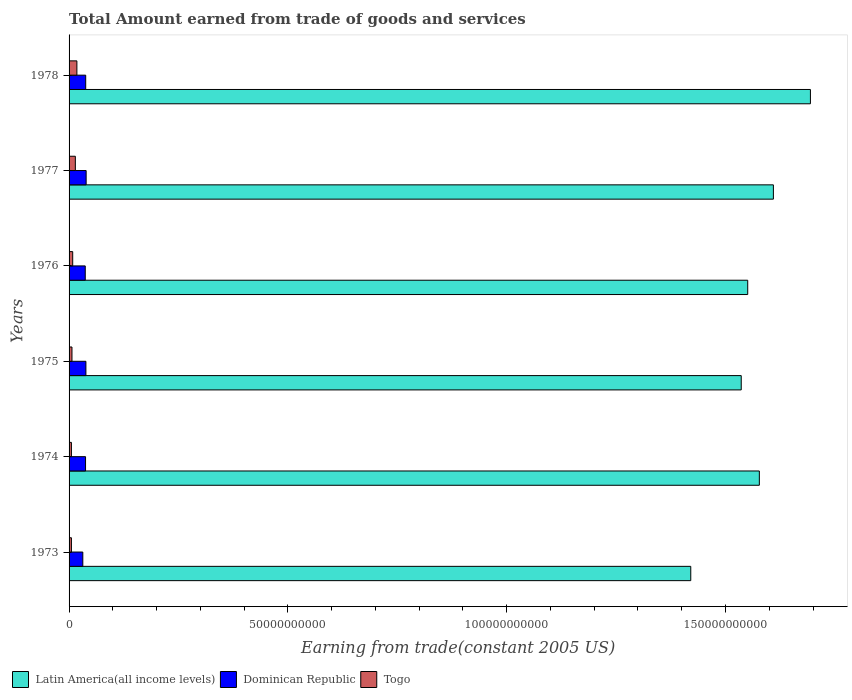Are the number of bars per tick equal to the number of legend labels?
Make the answer very short. Yes. How many bars are there on the 3rd tick from the bottom?
Provide a succinct answer. 3. What is the label of the 1st group of bars from the top?
Your response must be concise. 1978. What is the total amount earned by trading goods and services in Dominican Republic in 1973?
Offer a terse response. 3.14e+09. Across all years, what is the maximum total amount earned by trading goods and services in Dominican Republic?
Your answer should be compact. 3.90e+09. Across all years, what is the minimum total amount earned by trading goods and services in Togo?
Ensure brevity in your answer.  5.37e+08. In which year was the total amount earned by trading goods and services in Togo maximum?
Your response must be concise. 1978. What is the total total amount earned by trading goods and services in Latin America(all income levels) in the graph?
Provide a short and direct response. 9.39e+11. What is the difference between the total amount earned by trading goods and services in Latin America(all income levels) in 1974 and that in 1975?
Ensure brevity in your answer.  4.14e+09. What is the difference between the total amount earned by trading goods and services in Dominican Republic in 1977 and the total amount earned by trading goods and services in Togo in 1975?
Offer a terse response. 3.24e+09. What is the average total amount earned by trading goods and services in Togo per year?
Offer a very short reply. 9.64e+08. In the year 1974, what is the difference between the total amount earned by trading goods and services in Togo and total amount earned by trading goods and services in Latin America(all income levels)?
Your answer should be compact. -1.57e+11. What is the ratio of the total amount earned by trading goods and services in Togo in 1973 to that in 1974?
Provide a succinct answer. 1. What is the difference between the highest and the second highest total amount earned by trading goods and services in Dominican Republic?
Keep it short and to the point. 5.34e+07. What is the difference between the highest and the lowest total amount earned by trading goods and services in Togo?
Give a very brief answer. 1.25e+09. What does the 1st bar from the top in 1973 represents?
Give a very brief answer. Togo. What does the 3rd bar from the bottom in 1975 represents?
Your response must be concise. Togo. Is it the case that in every year, the sum of the total amount earned by trading goods and services in Dominican Republic and total amount earned by trading goods and services in Latin America(all income levels) is greater than the total amount earned by trading goods and services in Togo?
Provide a short and direct response. Yes. How many bars are there?
Give a very brief answer. 18. How many years are there in the graph?
Offer a terse response. 6. Does the graph contain any zero values?
Offer a terse response. No. Does the graph contain grids?
Offer a terse response. No. How many legend labels are there?
Provide a succinct answer. 3. How are the legend labels stacked?
Your answer should be compact. Horizontal. What is the title of the graph?
Your answer should be compact. Total Amount earned from trade of goods and services. Does "Burundi" appear as one of the legend labels in the graph?
Make the answer very short. No. What is the label or title of the X-axis?
Ensure brevity in your answer.  Earning from trade(constant 2005 US). What is the label or title of the Y-axis?
Keep it short and to the point. Years. What is the Earning from trade(constant 2005 US) in Latin America(all income levels) in 1973?
Your answer should be compact. 1.42e+11. What is the Earning from trade(constant 2005 US) of Dominican Republic in 1973?
Offer a very short reply. 3.14e+09. What is the Earning from trade(constant 2005 US) of Togo in 1973?
Your answer should be very brief. 5.37e+08. What is the Earning from trade(constant 2005 US) in Latin America(all income levels) in 1974?
Provide a short and direct response. 1.58e+11. What is the Earning from trade(constant 2005 US) in Dominican Republic in 1974?
Your answer should be very brief. 3.77e+09. What is the Earning from trade(constant 2005 US) of Togo in 1974?
Provide a succinct answer. 5.37e+08. What is the Earning from trade(constant 2005 US) in Latin America(all income levels) in 1975?
Offer a terse response. 1.54e+11. What is the Earning from trade(constant 2005 US) of Dominican Republic in 1975?
Provide a short and direct response. 3.85e+09. What is the Earning from trade(constant 2005 US) of Togo in 1975?
Provide a succinct answer. 6.61e+08. What is the Earning from trade(constant 2005 US) of Latin America(all income levels) in 1976?
Your response must be concise. 1.55e+11. What is the Earning from trade(constant 2005 US) of Dominican Republic in 1976?
Offer a terse response. 3.70e+09. What is the Earning from trade(constant 2005 US) in Togo in 1976?
Give a very brief answer. 8.29e+08. What is the Earning from trade(constant 2005 US) in Latin America(all income levels) in 1977?
Offer a terse response. 1.61e+11. What is the Earning from trade(constant 2005 US) of Dominican Republic in 1977?
Ensure brevity in your answer.  3.90e+09. What is the Earning from trade(constant 2005 US) in Togo in 1977?
Provide a short and direct response. 1.43e+09. What is the Earning from trade(constant 2005 US) of Latin America(all income levels) in 1978?
Provide a succinct answer. 1.69e+11. What is the Earning from trade(constant 2005 US) of Dominican Republic in 1978?
Offer a terse response. 3.80e+09. What is the Earning from trade(constant 2005 US) in Togo in 1978?
Provide a short and direct response. 1.79e+09. Across all years, what is the maximum Earning from trade(constant 2005 US) in Latin America(all income levels)?
Give a very brief answer. 1.69e+11. Across all years, what is the maximum Earning from trade(constant 2005 US) in Dominican Republic?
Make the answer very short. 3.90e+09. Across all years, what is the maximum Earning from trade(constant 2005 US) in Togo?
Your answer should be very brief. 1.79e+09. Across all years, what is the minimum Earning from trade(constant 2005 US) of Latin America(all income levels)?
Offer a terse response. 1.42e+11. Across all years, what is the minimum Earning from trade(constant 2005 US) of Dominican Republic?
Provide a succinct answer. 3.14e+09. Across all years, what is the minimum Earning from trade(constant 2005 US) in Togo?
Offer a terse response. 5.37e+08. What is the total Earning from trade(constant 2005 US) of Latin America(all income levels) in the graph?
Give a very brief answer. 9.39e+11. What is the total Earning from trade(constant 2005 US) in Dominican Republic in the graph?
Your answer should be very brief. 2.22e+1. What is the total Earning from trade(constant 2005 US) of Togo in the graph?
Your response must be concise. 5.78e+09. What is the difference between the Earning from trade(constant 2005 US) in Latin America(all income levels) in 1973 and that in 1974?
Make the answer very short. -1.57e+1. What is the difference between the Earning from trade(constant 2005 US) of Dominican Republic in 1973 and that in 1974?
Give a very brief answer. -6.24e+08. What is the difference between the Earning from trade(constant 2005 US) in Togo in 1973 and that in 1974?
Ensure brevity in your answer.  0. What is the difference between the Earning from trade(constant 2005 US) of Latin America(all income levels) in 1973 and that in 1975?
Your answer should be very brief. -1.15e+1. What is the difference between the Earning from trade(constant 2005 US) in Dominican Republic in 1973 and that in 1975?
Provide a succinct answer. -7.05e+08. What is the difference between the Earning from trade(constant 2005 US) in Togo in 1973 and that in 1975?
Keep it short and to the point. -1.24e+08. What is the difference between the Earning from trade(constant 2005 US) of Latin America(all income levels) in 1973 and that in 1976?
Your answer should be compact. -1.30e+1. What is the difference between the Earning from trade(constant 2005 US) of Dominican Republic in 1973 and that in 1976?
Offer a terse response. -5.55e+08. What is the difference between the Earning from trade(constant 2005 US) in Togo in 1973 and that in 1976?
Ensure brevity in your answer.  -2.91e+08. What is the difference between the Earning from trade(constant 2005 US) of Latin America(all income levels) in 1973 and that in 1977?
Ensure brevity in your answer.  -1.89e+1. What is the difference between the Earning from trade(constant 2005 US) of Dominican Republic in 1973 and that in 1977?
Ensure brevity in your answer.  -7.59e+08. What is the difference between the Earning from trade(constant 2005 US) in Togo in 1973 and that in 1977?
Offer a terse response. -8.94e+08. What is the difference between the Earning from trade(constant 2005 US) in Latin America(all income levels) in 1973 and that in 1978?
Offer a terse response. -2.73e+1. What is the difference between the Earning from trade(constant 2005 US) in Dominican Republic in 1973 and that in 1978?
Your answer should be compact. -6.60e+08. What is the difference between the Earning from trade(constant 2005 US) in Togo in 1973 and that in 1978?
Offer a very short reply. -1.25e+09. What is the difference between the Earning from trade(constant 2005 US) of Latin America(all income levels) in 1974 and that in 1975?
Give a very brief answer. 4.14e+09. What is the difference between the Earning from trade(constant 2005 US) in Dominican Republic in 1974 and that in 1975?
Your response must be concise. -8.16e+07. What is the difference between the Earning from trade(constant 2005 US) of Togo in 1974 and that in 1975?
Ensure brevity in your answer.  -1.24e+08. What is the difference between the Earning from trade(constant 2005 US) of Latin America(all income levels) in 1974 and that in 1976?
Give a very brief answer. 2.66e+09. What is the difference between the Earning from trade(constant 2005 US) of Dominican Republic in 1974 and that in 1976?
Ensure brevity in your answer.  6.86e+07. What is the difference between the Earning from trade(constant 2005 US) in Togo in 1974 and that in 1976?
Give a very brief answer. -2.91e+08. What is the difference between the Earning from trade(constant 2005 US) of Latin America(all income levels) in 1974 and that in 1977?
Provide a short and direct response. -3.21e+09. What is the difference between the Earning from trade(constant 2005 US) of Dominican Republic in 1974 and that in 1977?
Your answer should be compact. -1.35e+08. What is the difference between the Earning from trade(constant 2005 US) in Togo in 1974 and that in 1977?
Your response must be concise. -8.94e+08. What is the difference between the Earning from trade(constant 2005 US) of Latin America(all income levels) in 1974 and that in 1978?
Your answer should be compact. -1.17e+1. What is the difference between the Earning from trade(constant 2005 US) in Dominican Republic in 1974 and that in 1978?
Keep it short and to the point. -3.59e+07. What is the difference between the Earning from trade(constant 2005 US) in Togo in 1974 and that in 1978?
Ensure brevity in your answer.  -1.25e+09. What is the difference between the Earning from trade(constant 2005 US) in Latin America(all income levels) in 1975 and that in 1976?
Ensure brevity in your answer.  -1.48e+09. What is the difference between the Earning from trade(constant 2005 US) of Dominican Republic in 1975 and that in 1976?
Ensure brevity in your answer.  1.50e+08. What is the difference between the Earning from trade(constant 2005 US) in Togo in 1975 and that in 1976?
Provide a succinct answer. -1.68e+08. What is the difference between the Earning from trade(constant 2005 US) of Latin America(all income levels) in 1975 and that in 1977?
Your answer should be compact. -7.35e+09. What is the difference between the Earning from trade(constant 2005 US) of Dominican Republic in 1975 and that in 1977?
Give a very brief answer. -5.34e+07. What is the difference between the Earning from trade(constant 2005 US) of Togo in 1975 and that in 1977?
Your response must be concise. -7.71e+08. What is the difference between the Earning from trade(constant 2005 US) of Latin America(all income levels) in 1975 and that in 1978?
Give a very brief answer. -1.58e+1. What is the difference between the Earning from trade(constant 2005 US) in Dominican Republic in 1975 and that in 1978?
Offer a very short reply. 4.57e+07. What is the difference between the Earning from trade(constant 2005 US) in Togo in 1975 and that in 1978?
Make the answer very short. -1.13e+09. What is the difference between the Earning from trade(constant 2005 US) of Latin America(all income levels) in 1976 and that in 1977?
Make the answer very short. -5.86e+09. What is the difference between the Earning from trade(constant 2005 US) of Dominican Republic in 1976 and that in 1977?
Your response must be concise. -2.04e+08. What is the difference between the Earning from trade(constant 2005 US) in Togo in 1976 and that in 1977?
Make the answer very short. -6.03e+08. What is the difference between the Earning from trade(constant 2005 US) in Latin America(all income levels) in 1976 and that in 1978?
Your answer should be compact. -1.43e+1. What is the difference between the Earning from trade(constant 2005 US) in Dominican Republic in 1976 and that in 1978?
Give a very brief answer. -1.05e+08. What is the difference between the Earning from trade(constant 2005 US) in Togo in 1976 and that in 1978?
Your answer should be very brief. -9.59e+08. What is the difference between the Earning from trade(constant 2005 US) in Latin America(all income levels) in 1977 and that in 1978?
Keep it short and to the point. -8.46e+09. What is the difference between the Earning from trade(constant 2005 US) of Dominican Republic in 1977 and that in 1978?
Your response must be concise. 9.90e+07. What is the difference between the Earning from trade(constant 2005 US) in Togo in 1977 and that in 1978?
Offer a terse response. -3.55e+08. What is the difference between the Earning from trade(constant 2005 US) in Latin America(all income levels) in 1973 and the Earning from trade(constant 2005 US) in Dominican Republic in 1974?
Your answer should be very brief. 1.38e+11. What is the difference between the Earning from trade(constant 2005 US) of Latin America(all income levels) in 1973 and the Earning from trade(constant 2005 US) of Togo in 1974?
Provide a short and direct response. 1.42e+11. What is the difference between the Earning from trade(constant 2005 US) of Dominican Republic in 1973 and the Earning from trade(constant 2005 US) of Togo in 1974?
Your response must be concise. 2.60e+09. What is the difference between the Earning from trade(constant 2005 US) of Latin America(all income levels) in 1973 and the Earning from trade(constant 2005 US) of Dominican Republic in 1975?
Your answer should be very brief. 1.38e+11. What is the difference between the Earning from trade(constant 2005 US) in Latin America(all income levels) in 1973 and the Earning from trade(constant 2005 US) in Togo in 1975?
Offer a terse response. 1.41e+11. What is the difference between the Earning from trade(constant 2005 US) in Dominican Republic in 1973 and the Earning from trade(constant 2005 US) in Togo in 1975?
Ensure brevity in your answer.  2.48e+09. What is the difference between the Earning from trade(constant 2005 US) of Latin America(all income levels) in 1973 and the Earning from trade(constant 2005 US) of Dominican Republic in 1976?
Make the answer very short. 1.38e+11. What is the difference between the Earning from trade(constant 2005 US) in Latin America(all income levels) in 1973 and the Earning from trade(constant 2005 US) in Togo in 1976?
Give a very brief answer. 1.41e+11. What is the difference between the Earning from trade(constant 2005 US) of Dominican Republic in 1973 and the Earning from trade(constant 2005 US) of Togo in 1976?
Offer a terse response. 2.31e+09. What is the difference between the Earning from trade(constant 2005 US) in Latin America(all income levels) in 1973 and the Earning from trade(constant 2005 US) in Dominican Republic in 1977?
Ensure brevity in your answer.  1.38e+11. What is the difference between the Earning from trade(constant 2005 US) of Latin America(all income levels) in 1973 and the Earning from trade(constant 2005 US) of Togo in 1977?
Ensure brevity in your answer.  1.41e+11. What is the difference between the Earning from trade(constant 2005 US) of Dominican Republic in 1973 and the Earning from trade(constant 2005 US) of Togo in 1977?
Make the answer very short. 1.71e+09. What is the difference between the Earning from trade(constant 2005 US) in Latin America(all income levels) in 1973 and the Earning from trade(constant 2005 US) in Dominican Republic in 1978?
Keep it short and to the point. 1.38e+11. What is the difference between the Earning from trade(constant 2005 US) of Latin America(all income levels) in 1973 and the Earning from trade(constant 2005 US) of Togo in 1978?
Provide a succinct answer. 1.40e+11. What is the difference between the Earning from trade(constant 2005 US) of Dominican Republic in 1973 and the Earning from trade(constant 2005 US) of Togo in 1978?
Your answer should be very brief. 1.35e+09. What is the difference between the Earning from trade(constant 2005 US) of Latin America(all income levels) in 1974 and the Earning from trade(constant 2005 US) of Dominican Republic in 1975?
Keep it short and to the point. 1.54e+11. What is the difference between the Earning from trade(constant 2005 US) of Latin America(all income levels) in 1974 and the Earning from trade(constant 2005 US) of Togo in 1975?
Your answer should be compact. 1.57e+11. What is the difference between the Earning from trade(constant 2005 US) in Dominican Republic in 1974 and the Earning from trade(constant 2005 US) in Togo in 1975?
Your answer should be compact. 3.10e+09. What is the difference between the Earning from trade(constant 2005 US) in Latin America(all income levels) in 1974 and the Earning from trade(constant 2005 US) in Dominican Republic in 1976?
Offer a terse response. 1.54e+11. What is the difference between the Earning from trade(constant 2005 US) in Latin America(all income levels) in 1974 and the Earning from trade(constant 2005 US) in Togo in 1976?
Your answer should be compact. 1.57e+11. What is the difference between the Earning from trade(constant 2005 US) in Dominican Republic in 1974 and the Earning from trade(constant 2005 US) in Togo in 1976?
Your response must be concise. 2.94e+09. What is the difference between the Earning from trade(constant 2005 US) in Latin America(all income levels) in 1974 and the Earning from trade(constant 2005 US) in Dominican Republic in 1977?
Your answer should be very brief. 1.54e+11. What is the difference between the Earning from trade(constant 2005 US) in Latin America(all income levels) in 1974 and the Earning from trade(constant 2005 US) in Togo in 1977?
Ensure brevity in your answer.  1.56e+11. What is the difference between the Earning from trade(constant 2005 US) of Dominican Republic in 1974 and the Earning from trade(constant 2005 US) of Togo in 1977?
Your answer should be very brief. 2.33e+09. What is the difference between the Earning from trade(constant 2005 US) in Latin America(all income levels) in 1974 and the Earning from trade(constant 2005 US) in Dominican Republic in 1978?
Offer a terse response. 1.54e+11. What is the difference between the Earning from trade(constant 2005 US) in Latin America(all income levels) in 1974 and the Earning from trade(constant 2005 US) in Togo in 1978?
Keep it short and to the point. 1.56e+11. What is the difference between the Earning from trade(constant 2005 US) of Dominican Republic in 1974 and the Earning from trade(constant 2005 US) of Togo in 1978?
Give a very brief answer. 1.98e+09. What is the difference between the Earning from trade(constant 2005 US) of Latin America(all income levels) in 1975 and the Earning from trade(constant 2005 US) of Dominican Republic in 1976?
Make the answer very short. 1.50e+11. What is the difference between the Earning from trade(constant 2005 US) of Latin America(all income levels) in 1975 and the Earning from trade(constant 2005 US) of Togo in 1976?
Offer a terse response. 1.53e+11. What is the difference between the Earning from trade(constant 2005 US) of Dominican Republic in 1975 and the Earning from trade(constant 2005 US) of Togo in 1976?
Provide a short and direct response. 3.02e+09. What is the difference between the Earning from trade(constant 2005 US) in Latin America(all income levels) in 1975 and the Earning from trade(constant 2005 US) in Dominican Republic in 1977?
Ensure brevity in your answer.  1.50e+11. What is the difference between the Earning from trade(constant 2005 US) in Latin America(all income levels) in 1975 and the Earning from trade(constant 2005 US) in Togo in 1977?
Ensure brevity in your answer.  1.52e+11. What is the difference between the Earning from trade(constant 2005 US) of Dominican Republic in 1975 and the Earning from trade(constant 2005 US) of Togo in 1977?
Your answer should be compact. 2.42e+09. What is the difference between the Earning from trade(constant 2005 US) in Latin America(all income levels) in 1975 and the Earning from trade(constant 2005 US) in Dominican Republic in 1978?
Your answer should be very brief. 1.50e+11. What is the difference between the Earning from trade(constant 2005 US) of Latin America(all income levels) in 1975 and the Earning from trade(constant 2005 US) of Togo in 1978?
Give a very brief answer. 1.52e+11. What is the difference between the Earning from trade(constant 2005 US) in Dominican Republic in 1975 and the Earning from trade(constant 2005 US) in Togo in 1978?
Give a very brief answer. 2.06e+09. What is the difference between the Earning from trade(constant 2005 US) of Latin America(all income levels) in 1976 and the Earning from trade(constant 2005 US) of Dominican Republic in 1977?
Offer a terse response. 1.51e+11. What is the difference between the Earning from trade(constant 2005 US) in Latin America(all income levels) in 1976 and the Earning from trade(constant 2005 US) in Togo in 1977?
Offer a terse response. 1.54e+11. What is the difference between the Earning from trade(constant 2005 US) of Dominican Republic in 1976 and the Earning from trade(constant 2005 US) of Togo in 1977?
Give a very brief answer. 2.26e+09. What is the difference between the Earning from trade(constant 2005 US) of Latin America(all income levels) in 1976 and the Earning from trade(constant 2005 US) of Dominican Republic in 1978?
Your answer should be very brief. 1.51e+11. What is the difference between the Earning from trade(constant 2005 US) of Latin America(all income levels) in 1976 and the Earning from trade(constant 2005 US) of Togo in 1978?
Provide a succinct answer. 1.53e+11. What is the difference between the Earning from trade(constant 2005 US) of Dominican Republic in 1976 and the Earning from trade(constant 2005 US) of Togo in 1978?
Give a very brief answer. 1.91e+09. What is the difference between the Earning from trade(constant 2005 US) of Latin America(all income levels) in 1977 and the Earning from trade(constant 2005 US) of Dominican Republic in 1978?
Your response must be concise. 1.57e+11. What is the difference between the Earning from trade(constant 2005 US) of Latin America(all income levels) in 1977 and the Earning from trade(constant 2005 US) of Togo in 1978?
Give a very brief answer. 1.59e+11. What is the difference between the Earning from trade(constant 2005 US) in Dominican Republic in 1977 and the Earning from trade(constant 2005 US) in Togo in 1978?
Give a very brief answer. 2.11e+09. What is the average Earning from trade(constant 2005 US) of Latin America(all income levels) per year?
Your answer should be very brief. 1.56e+11. What is the average Earning from trade(constant 2005 US) in Dominican Republic per year?
Your response must be concise. 3.69e+09. What is the average Earning from trade(constant 2005 US) in Togo per year?
Provide a succinct answer. 9.64e+08. In the year 1973, what is the difference between the Earning from trade(constant 2005 US) in Latin America(all income levels) and Earning from trade(constant 2005 US) in Dominican Republic?
Give a very brief answer. 1.39e+11. In the year 1973, what is the difference between the Earning from trade(constant 2005 US) in Latin America(all income levels) and Earning from trade(constant 2005 US) in Togo?
Your response must be concise. 1.42e+11. In the year 1973, what is the difference between the Earning from trade(constant 2005 US) in Dominican Republic and Earning from trade(constant 2005 US) in Togo?
Your answer should be compact. 2.60e+09. In the year 1974, what is the difference between the Earning from trade(constant 2005 US) of Latin America(all income levels) and Earning from trade(constant 2005 US) of Dominican Republic?
Offer a terse response. 1.54e+11. In the year 1974, what is the difference between the Earning from trade(constant 2005 US) of Latin America(all income levels) and Earning from trade(constant 2005 US) of Togo?
Give a very brief answer. 1.57e+11. In the year 1974, what is the difference between the Earning from trade(constant 2005 US) of Dominican Republic and Earning from trade(constant 2005 US) of Togo?
Ensure brevity in your answer.  3.23e+09. In the year 1975, what is the difference between the Earning from trade(constant 2005 US) of Latin America(all income levels) and Earning from trade(constant 2005 US) of Dominican Republic?
Give a very brief answer. 1.50e+11. In the year 1975, what is the difference between the Earning from trade(constant 2005 US) in Latin America(all income levels) and Earning from trade(constant 2005 US) in Togo?
Keep it short and to the point. 1.53e+11. In the year 1975, what is the difference between the Earning from trade(constant 2005 US) in Dominican Republic and Earning from trade(constant 2005 US) in Togo?
Offer a terse response. 3.19e+09. In the year 1976, what is the difference between the Earning from trade(constant 2005 US) of Latin America(all income levels) and Earning from trade(constant 2005 US) of Dominican Republic?
Provide a short and direct response. 1.51e+11. In the year 1976, what is the difference between the Earning from trade(constant 2005 US) of Latin America(all income levels) and Earning from trade(constant 2005 US) of Togo?
Your response must be concise. 1.54e+11. In the year 1976, what is the difference between the Earning from trade(constant 2005 US) in Dominican Republic and Earning from trade(constant 2005 US) in Togo?
Keep it short and to the point. 2.87e+09. In the year 1977, what is the difference between the Earning from trade(constant 2005 US) of Latin America(all income levels) and Earning from trade(constant 2005 US) of Dominican Republic?
Your answer should be compact. 1.57e+11. In the year 1977, what is the difference between the Earning from trade(constant 2005 US) of Latin America(all income levels) and Earning from trade(constant 2005 US) of Togo?
Give a very brief answer. 1.60e+11. In the year 1977, what is the difference between the Earning from trade(constant 2005 US) of Dominican Republic and Earning from trade(constant 2005 US) of Togo?
Offer a terse response. 2.47e+09. In the year 1978, what is the difference between the Earning from trade(constant 2005 US) of Latin America(all income levels) and Earning from trade(constant 2005 US) of Dominican Republic?
Provide a succinct answer. 1.66e+11. In the year 1978, what is the difference between the Earning from trade(constant 2005 US) of Latin America(all income levels) and Earning from trade(constant 2005 US) of Togo?
Your answer should be compact. 1.68e+11. In the year 1978, what is the difference between the Earning from trade(constant 2005 US) in Dominican Republic and Earning from trade(constant 2005 US) in Togo?
Offer a terse response. 2.01e+09. What is the ratio of the Earning from trade(constant 2005 US) in Latin America(all income levels) in 1973 to that in 1974?
Make the answer very short. 0.9. What is the ratio of the Earning from trade(constant 2005 US) of Dominican Republic in 1973 to that in 1974?
Offer a very short reply. 0.83. What is the ratio of the Earning from trade(constant 2005 US) of Togo in 1973 to that in 1974?
Provide a succinct answer. 1. What is the ratio of the Earning from trade(constant 2005 US) in Latin America(all income levels) in 1973 to that in 1975?
Offer a very short reply. 0.92. What is the ratio of the Earning from trade(constant 2005 US) in Dominican Republic in 1973 to that in 1975?
Your response must be concise. 0.82. What is the ratio of the Earning from trade(constant 2005 US) of Togo in 1973 to that in 1975?
Your answer should be compact. 0.81. What is the ratio of the Earning from trade(constant 2005 US) in Latin America(all income levels) in 1973 to that in 1976?
Keep it short and to the point. 0.92. What is the ratio of the Earning from trade(constant 2005 US) of Dominican Republic in 1973 to that in 1976?
Offer a very short reply. 0.85. What is the ratio of the Earning from trade(constant 2005 US) in Togo in 1973 to that in 1976?
Ensure brevity in your answer.  0.65. What is the ratio of the Earning from trade(constant 2005 US) in Latin America(all income levels) in 1973 to that in 1977?
Provide a short and direct response. 0.88. What is the ratio of the Earning from trade(constant 2005 US) in Dominican Republic in 1973 to that in 1977?
Provide a succinct answer. 0.81. What is the ratio of the Earning from trade(constant 2005 US) in Togo in 1973 to that in 1977?
Provide a short and direct response. 0.38. What is the ratio of the Earning from trade(constant 2005 US) of Latin America(all income levels) in 1973 to that in 1978?
Keep it short and to the point. 0.84. What is the ratio of the Earning from trade(constant 2005 US) of Dominican Republic in 1973 to that in 1978?
Your response must be concise. 0.83. What is the ratio of the Earning from trade(constant 2005 US) in Togo in 1973 to that in 1978?
Offer a terse response. 0.3. What is the ratio of the Earning from trade(constant 2005 US) in Dominican Republic in 1974 to that in 1975?
Keep it short and to the point. 0.98. What is the ratio of the Earning from trade(constant 2005 US) of Togo in 1974 to that in 1975?
Provide a short and direct response. 0.81. What is the ratio of the Earning from trade(constant 2005 US) of Latin America(all income levels) in 1974 to that in 1976?
Your response must be concise. 1.02. What is the ratio of the Earning from trade(constant 2005 US) of Dominican Republic in 1974 to that in 1976?
Keep it short and to the point. 1.02. What is the ratio of the Earning from trade(constant 2005 US) in Togo in 1974 to that in 1976?
Make the answer very short. 0.65. What is the ratio of the Earning from trade(constant 2005 US) of Latin America(all income levels) in 1974 to that in 1977?
Keep it short and to the point. 0.98. What is the ratio of the Earning from trade(constant 2005 US) of Dominican Republic in 1974 to that in 1977?
Ensure brevity in your answer.  0.97. What is the ratio of the Earning from trade(constant 2005 US) of Togo in 1974 to that in 1977?
Keep it short and to the point. 0.38. What is the ratio of the Earning from trade(constant 2005 US) in Latin America(all income levels) in 1974 to that in 1978?
Offer a terse response. 0.93. What is the ratio of the Earning from trade(constant 2005 US) in Togo in 1974 to that in 1978?
Your answer should be compact. 0.3. What is the ratio of the Earning from trade(constant 2005 US) of Dominican Republic in 1975 to that in 1976?
Make the answer very short. 1.04. What is the ratio of the Earning from trade(constant 2005 US) of Togo in 1975 to that in 1976?
Provide a short and direct response. 0.8. What is the ratio of the Earning from trade(constant 2005 US) in Latin America(all income levels) in 1975 to that in 1977?
Give a very brief answer. 0.95. What is the ratio of the Earning from trade(constant 2005 US) of Dominican Republic in 1975 to that in 1977?
Your response must be concise. 0.99. What is the ratio of the Earning from trade(constant 2005 US) of Togo in 1975 to that in 1977?
Offer a very short reply. 0.46. What is the ratio of the Earning from trade(constant 2005 US) of Latin America(all income levels) in 1975 to that in 1978?
Make the answer very short. 0.91. What is the ratio of the Earning from trade(constant 2005 US) of Togo in 1975 to that in 1978?
Provide a short and direct response. 0.37. What is the ratio of the Earning from trade(constant 2005 US) of Latin America(all income levels) in 1976 to that in 1977?
Make the answer very short. 0.96. What is the ratio of the Earning from trade(constant 2005 US) in Dominican Republic in 1976 to that in 1977?
Ensure brevity in your answer.  0.95. What is the ratio of the Earning from trade(constant 2005 US) of Togo in 1976 to that in 1977?
Ensure brevity in your answer.  0.58. What is the ratio of the Earning from trade(constant 2005 US) in Latin America(all income levels) in 1976 to that in 1978?
Ensure brevity in your answer.  0.92. What is the ratio of the Earning from trade(constant 2005 US) of Dominican Republic in 1976 to that in 1978?
Your answer should be compact. 0.97. What is the ratio of the Earning from trade(constant 2005 US) of Togo in 1976 to that in 1978?
Make the answer very short. 0.46. What is the ratio of the Earning from trade(constant 2005 US) of Latin America(all income levels) in 1977 to that in 1978?
Make the answer very short. 0.95. What is the ratio of the Earning from trade(constant 2005 US) in Togo in 1977 to that in 1978?
Provide a succinct answer. 0.8. What is the difference between the highest and the second highest Earning from trade(constant 2005 US) of Latin America(all income levels)?
Provide a succinct answer. 8.46e+09. What is the difference between the highest and the second highest Earning from trade(constant 2005 US) in Dominican Republic?
Keep it short and to the point. 5.34e+07. What is the difference between the highest and the second highest Earning from trade(constant 2005 US) of Togo?
Give a very brief answer. 3.55e+08. What is the difference between the highest and the lowest Earning from trade(constant 2005 US) of Latin America(all income levels)?
Your response must be concise. 2.73e+1. What is the difference between the highest and the lowest Earning from trade(constant 2005 US) in Dominican Republic?
Make the answer very short. 7.59e+08. What is the difference between the highest and the lowest Earning from trade(constant 2005 US) of Togo?
Provide a succinct answer. 1.25e+09. 